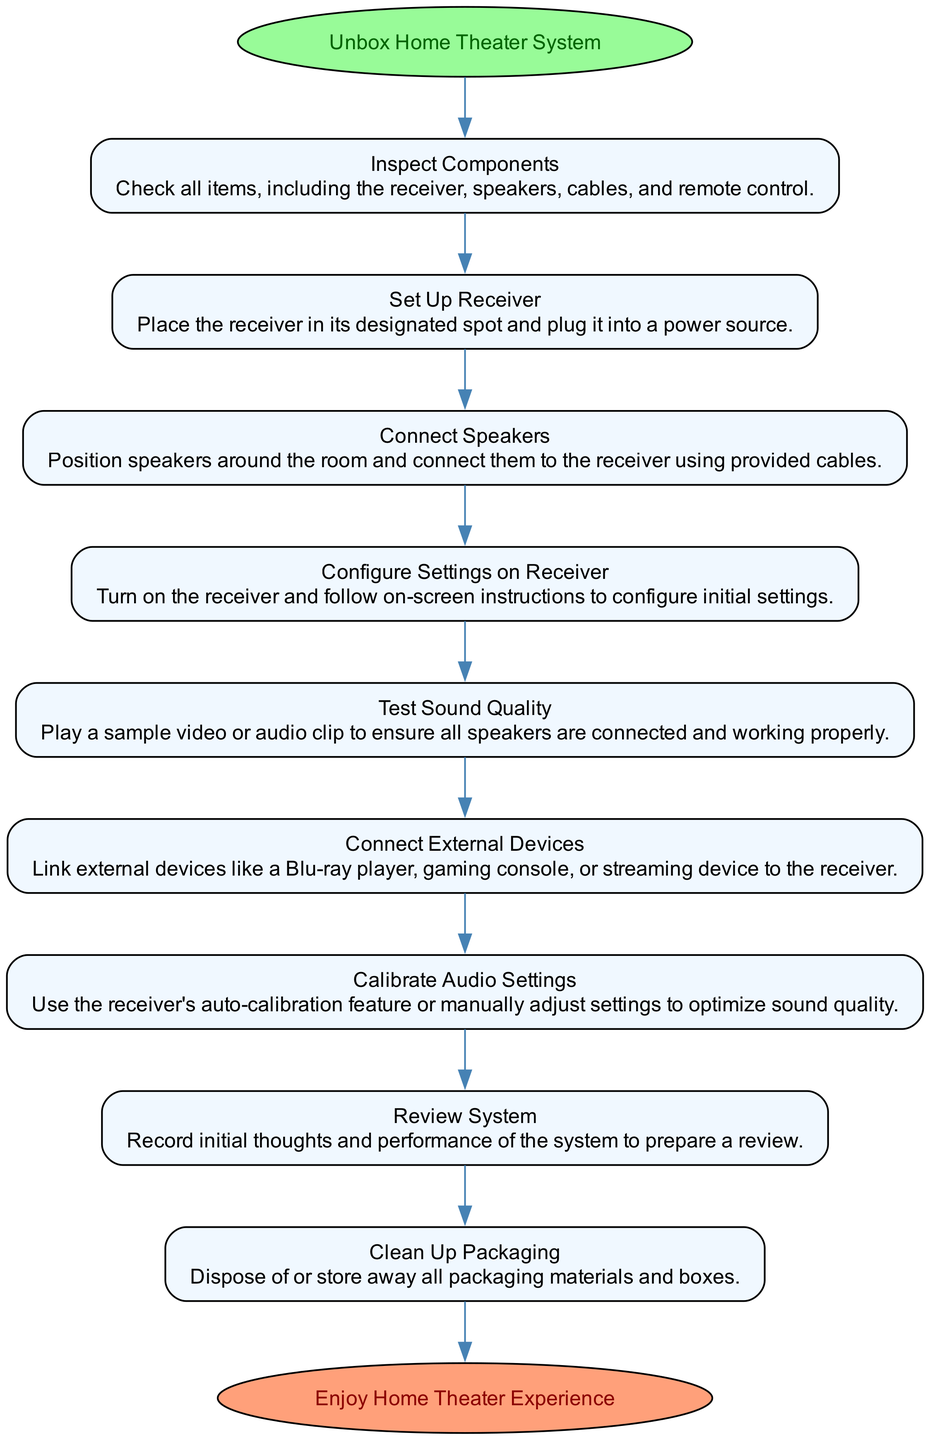What is the first action in the activity diagram? The first action listed in the diagram is "Unbox Home Theater System," which is indicated as the starting point of the process.
Answer: Unbox Home Theater System How many flows are there in the diagram? By counting the number of actions listed in the "Flows" section, we find a total of 9 actions that outline the process.
Answer: 9 What action comes directly after "Connect External Devices"? The action that follows "Connect External Devices" is "Calibrate Audio Settings," as indicated by the directed edge connecting these nodes in sequence.
Answer: Calibrate Audio Settings What is the last action before the end of the diagram? The last action before reaching the "Enjoy Home Theater Experience" end node is "Clean Up Packaging," which is the final step listed in the sequence of flows.
Answer: Clean Up Packaging What type of node is "Enjoy Home Theater Experience"? In the diagram, "Enjoy Home Theater Experience" is categorized as an end node, shown with an ellipse shape and different color to signify the conclusion of the process.
Answer: End node Which action involves checking items of the system? The action labeled "Inspect Components" specifically involves checking all components included in the home theater package.
Answer: Inspect Components Which two actions are most related to sound? The actions "Test Sound Quality" and "Calibrate Audio Settings" directly relate to the audio aspect of the home theater system as they both focus on evaluating and optimizing sound performance.
Answer: Test Sound Quality and Calibrate Audio Settings What is the relationship between "Set Up Receiver" and "Connect Speakers"? "Set Up Receiver" is a prerequisite step that must be completed before "Connect Speakers," indicating a sequential dependency in the setup process of the home theater system.
Answer: Sequential dependency 